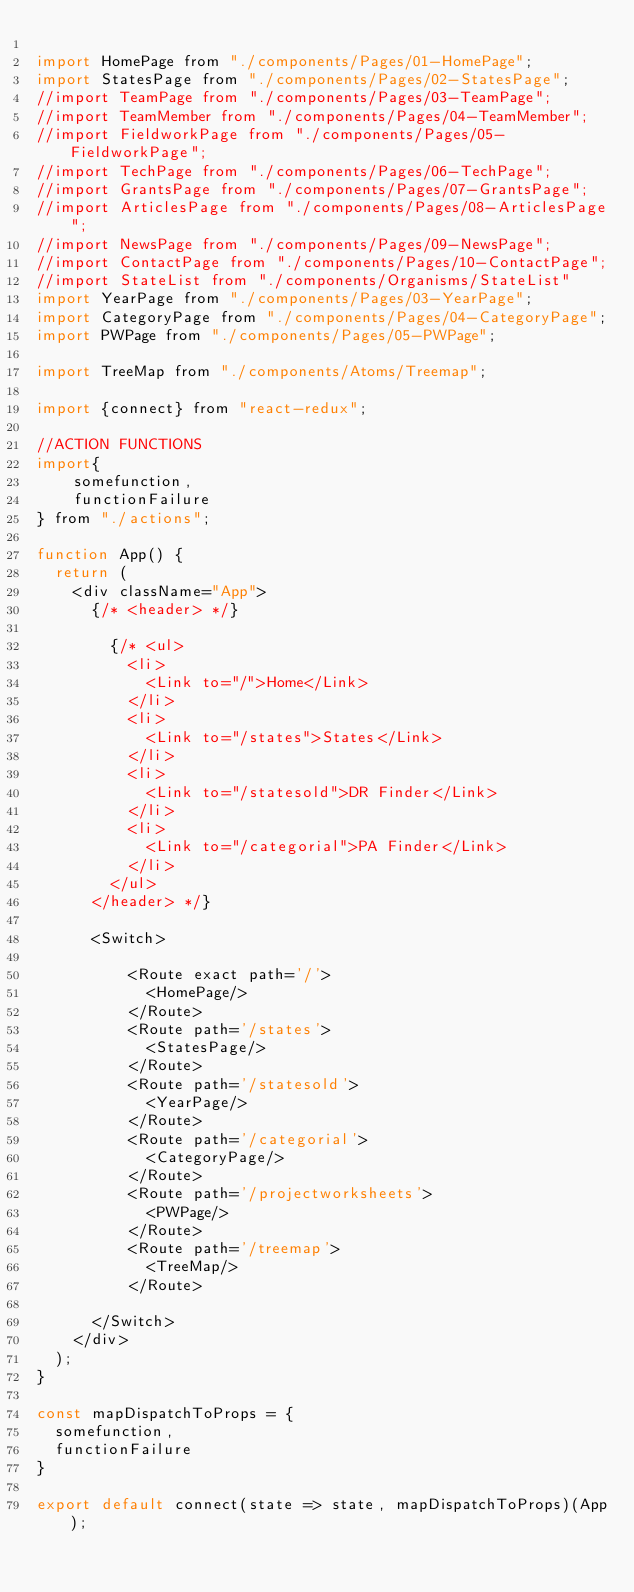Convert code to text. <code><loc_0><loc_0><loc_500><loc_500><_JavaScript_>
import HomePage from "./components/Pages/01-HomePage";
import StatesPage from "./components/Pages/02-StatesPage";
//import TeamPage from "./components/Pages/03-TeamPage";
//import TeamMember from "./components/Pages/04-TeamMember";
//import FieldworkPage from "./components/Pages/05-FieldworkPage";
//import TechPage from "./components/Pages/06-TechPage";
//import GrantsPage from "./components/Pages/07-GrantsPage";
//import ArticlesPage from "./components/Pages/08-ArticlesPage";
//import NewsPage from "./components/Pages/09-NewsPage";
//import ContactPage from "./components/Pages/10-ContactPage";
//import StateList from "./components/Organisms/StateList"
import YearPage from "./components/Pages/03-YearPage";
import CategoryPage from "./components/Pages/04-CategoryPage";
import PWPage from "./components/Pages/05-PWPage";

import TreeMap from "./components/Atoms/Treemap";

import {connect} from "react-redux";

//ACTION FUNCTIONS
import{
    somefunction,
    functionFailure
} from "./actions";

function App() {
  return (
    <div className="App">
      {/* <header> */}

        {/* <ul>
          <li>
            <Link to="/">Home</Link>
          </li>
          <li>
            <Link to="/states">States</Link>
          </li>
          <li>
            <Link to="/statesold">DR Finder</Link>
          </li>
          <li>
            <Link to="/categorial">PA Finder</Link>
          </li>
        </ul>
      </header> */}

      <Switch>

          <Route exact path='/'>
            <HomePage/>
          </Route>
          <Route path='/states'>
            <StatesPage/>
          </Route>  
          <Route path='/statesold'>
            <YearPage/>
          </Route>   
          <Route path='/categorial'>
            <CategoryPage/>
          </Route> 
          <Route path='/projectworksheets'>
            <PWPage/>
          </Route> 
          <Route path='/treemap'>
            <TreeMap/>
          </Route>

      </Switch>
    </div>
  );
}

const mapDispatchToProps = {
  somefunction,
  functionFailure
}

export default connect(state => state, mapDispatchToProps)(App);
</code> 